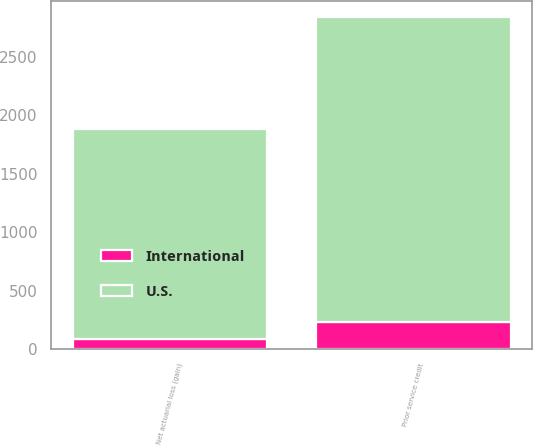Convert chart. <chart><loc_0><loc_0><loc_500><loc_500><stacked_bar_chart><ecel><fcel>Prior service credit<fcel>Net actuarial loss (gain)<nl><fcel>U.S.<fcel>2601<fcel>1797<nl><fcel>International<fcel>236<fcel>89<nl></chart> 